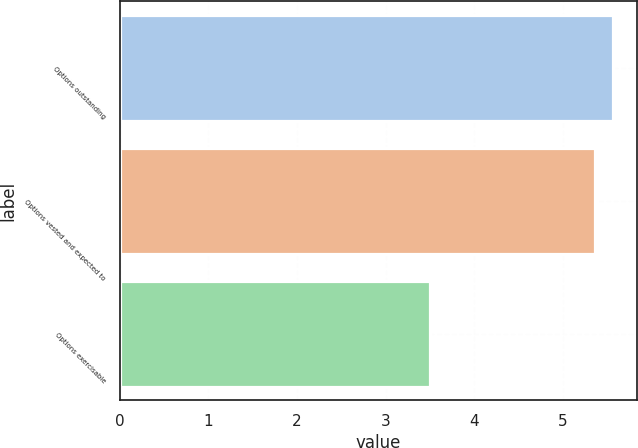Convert chart. <chart><loc_0><loc_0><loc_500><loc_500><bar_chart><fcel>Options outstanding<fcel>Options vested and expected to<fcel>Options exercisable<nl><fcel>5.56<fcel>5.36<fcel>3.5<nl></chart> 